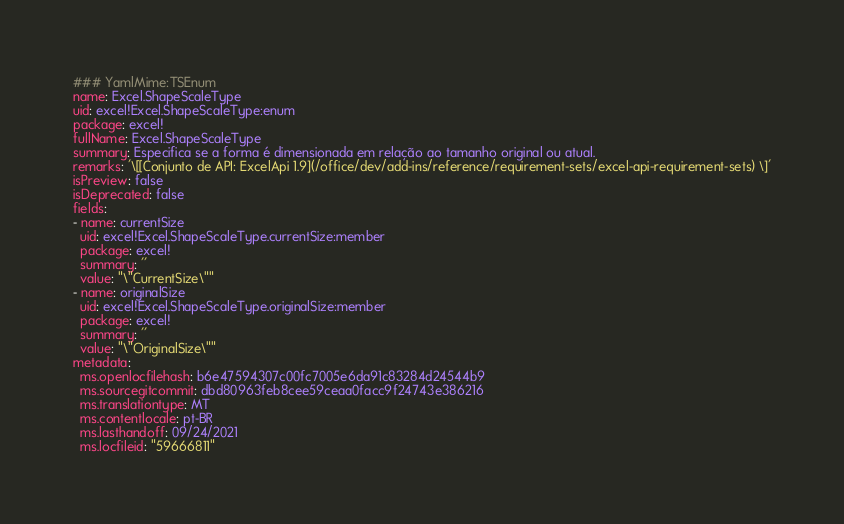Convert code to text. <code><loc_0><loc_0><loc_500><loc_500><_YAML_>### YamlMime:TSEnum
name: Excel.ShapeScaleType
uid: excel!Excel.ShapeScaleType:enum
package: excel!
fullName: Excel.ShapeScaleType
summary: Especifica se a forma é dimensionada em relação ao tamanho original ou atual.
remarks: '\[[Conjunto de API: ExcelApi 1.9](/office/dev/add-ins/reference/requirement-sets/excel-api-requirement-sets) \]'
isPreview: false
isDeprecated: false
fields:
- name: currentSize
  uid: excel!Excel.ShapeScaleType.currentSize:member
  package: excel!
  summary: ''
  value: "\"CurrentSize\""
- name: originalSize
  uid: excel!Excel.ShapeScaleType.originalSize:member
  package: excel!
  summary: ''
  value: "\"OriginalSize\""
metadata:
  ms.openlocfilehash: b6e47594307c00fc7005e6da91c83284d24544b9
  ms.sourcegitcommit: dbd80963feb8cee59ceaa0facc9f24743e386216
  ms.translationtype: MT
  ms.contentlocale: pt-BR
  ms.lasthandoff: 09/24/2021
  ms.locfileid: "59666811"
</code> 